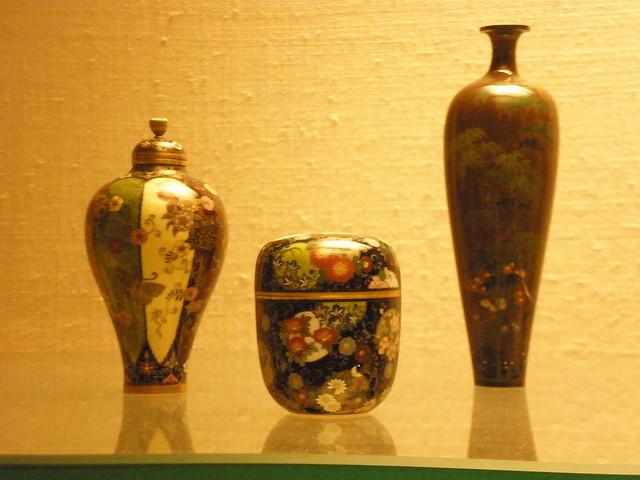Are these vases for show only?
Short answer required. Yes. How many of the vases have lids?
Write a very short answer. 2. Are the vases floating?
Write a very short answer. No. 